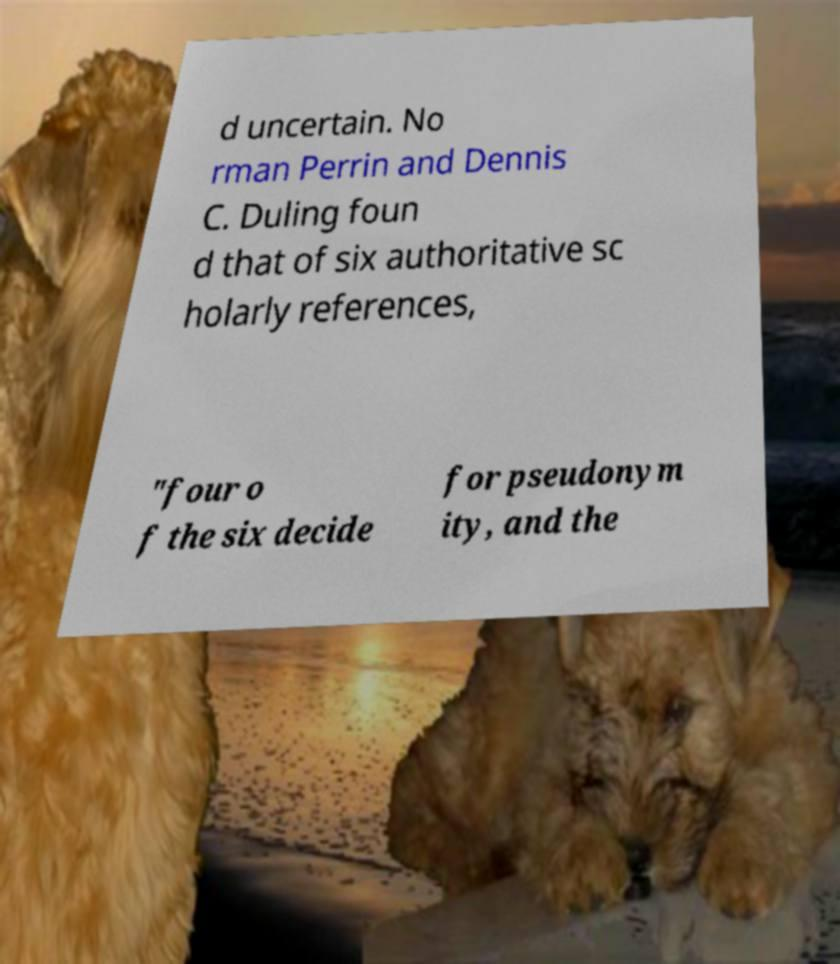Please identify and transcribe the text found in this image. d uncertain. No rman Perrin and Dennis C. Duling foun d that of six authoritative sc holarly references, "four o f the six decide for pseudonym ity, and the 